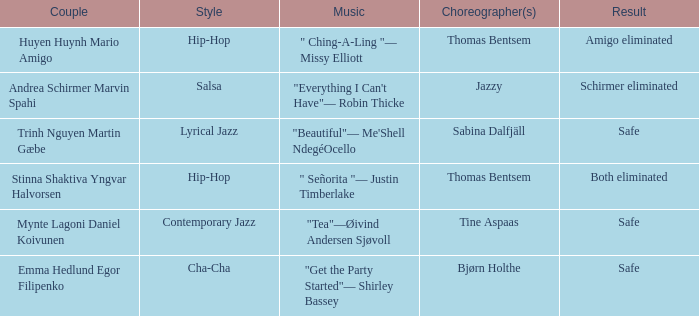What is the result of choreographer bjørn holthe? Safe. 